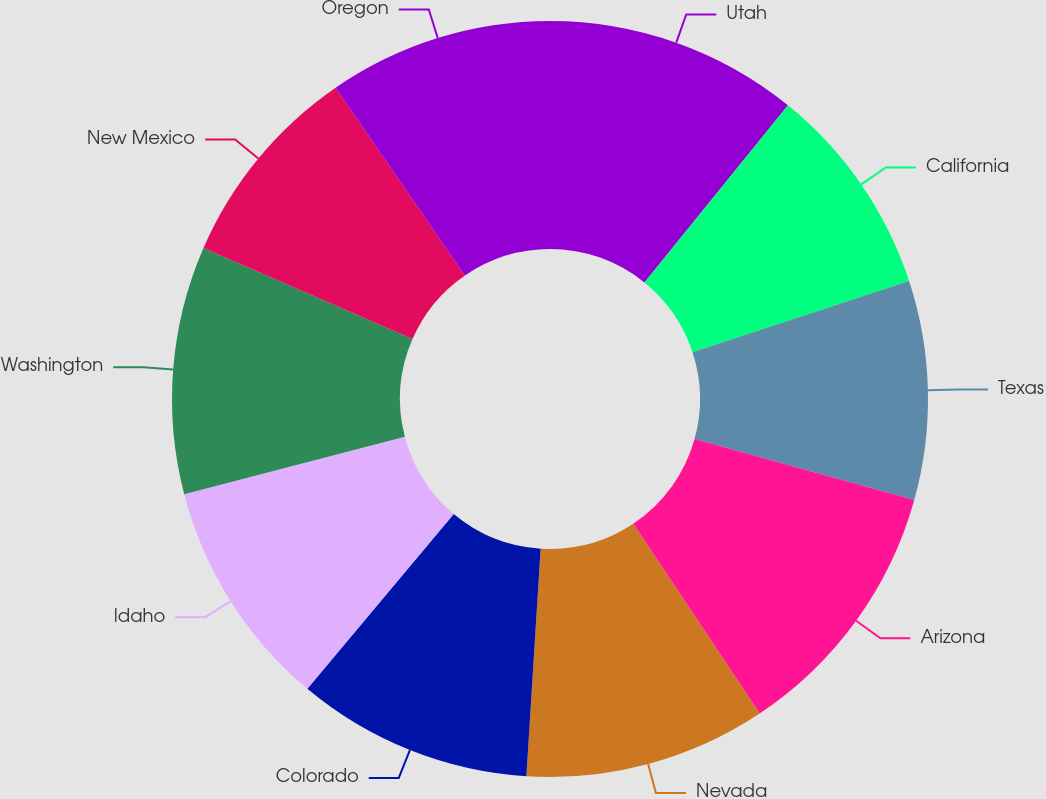Convert chart to OTSL. <chart><loc_0><loc_0><loc_500><loc_500><pie_chart><fcel>Utah<fcel>California<fcel>Texas<fcel>Arizona<fcel>Nevada<fcel>Colorado<fcel>Idaho<fcel>Washington<fcel>New Mexico<fcel>Oregon<nl><fcel>10.84%<fcel>9.11%<fcel>9.36%<fcel>11.34%<fcel>10.35%<fcel>10.1%<fcel>9.85%<fcel>10.6%<fcel>8.86%<fcel>9.6%<nl></chart> 